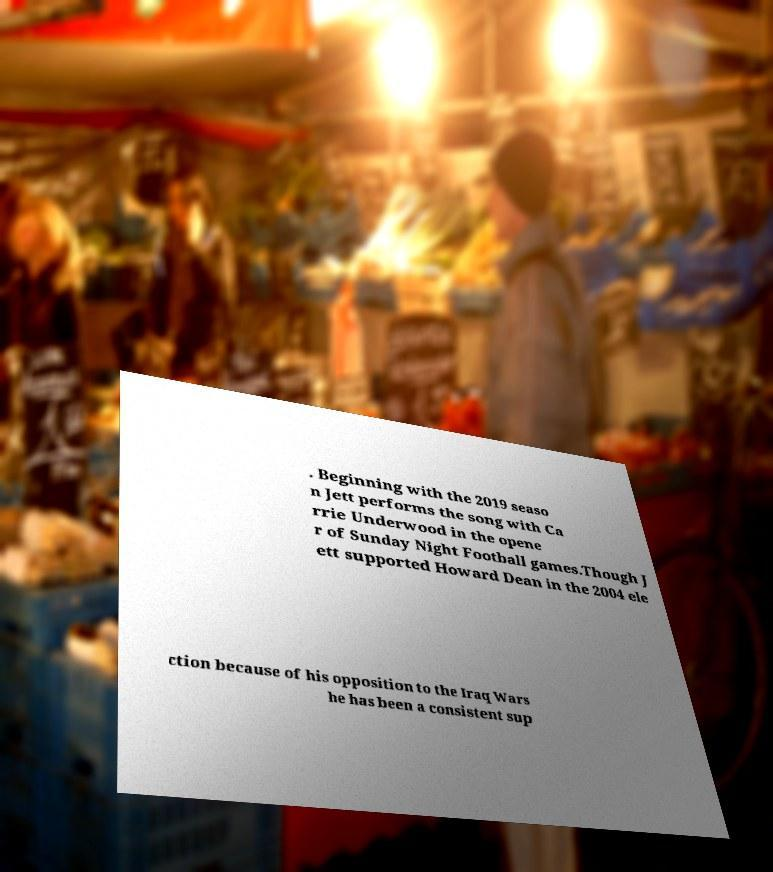Can you read and provide the text displayed in the image?This photo seems to have some interesting text. Can you extract and type it out for me? . Beginning with the 2019 seaso n Jett performs the song with Ca rrie Underwood in the opene r of Sunday Night Football games.Though J ett supported Howard Dean in the 2004 ele ction because of his opposition to the Iraq Wars he has been a consistent sup 